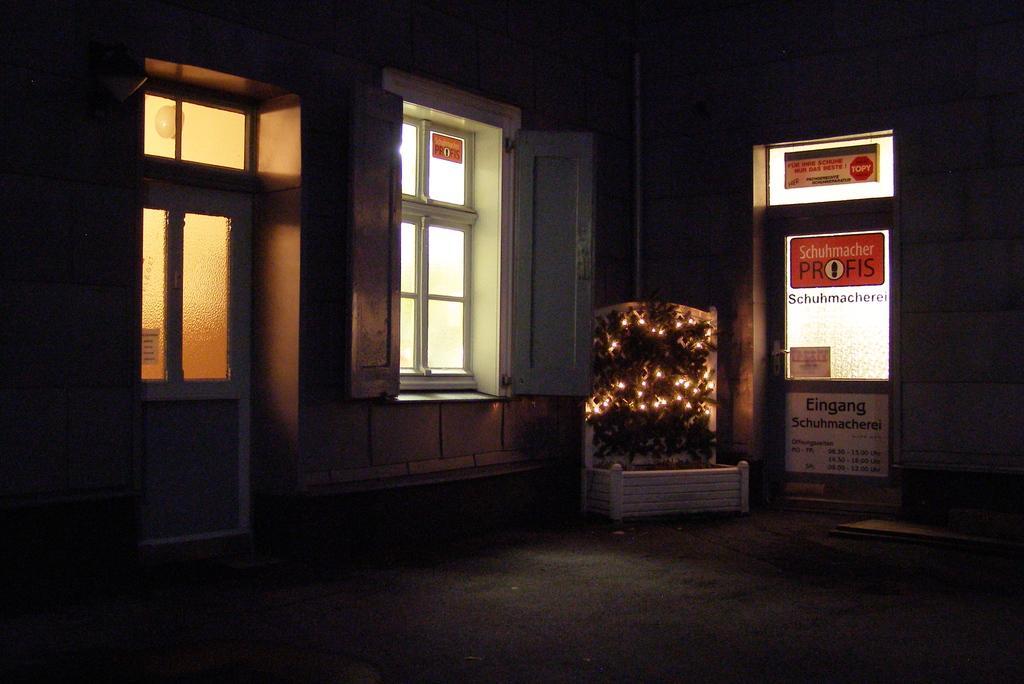In one or two sentences, can you explain what this image depicts? Here in the middle we can see a plant, which is decorated with lights present on the floor over there and beside that on either side we can see windows present and on the left side we can see a door also present over there. 